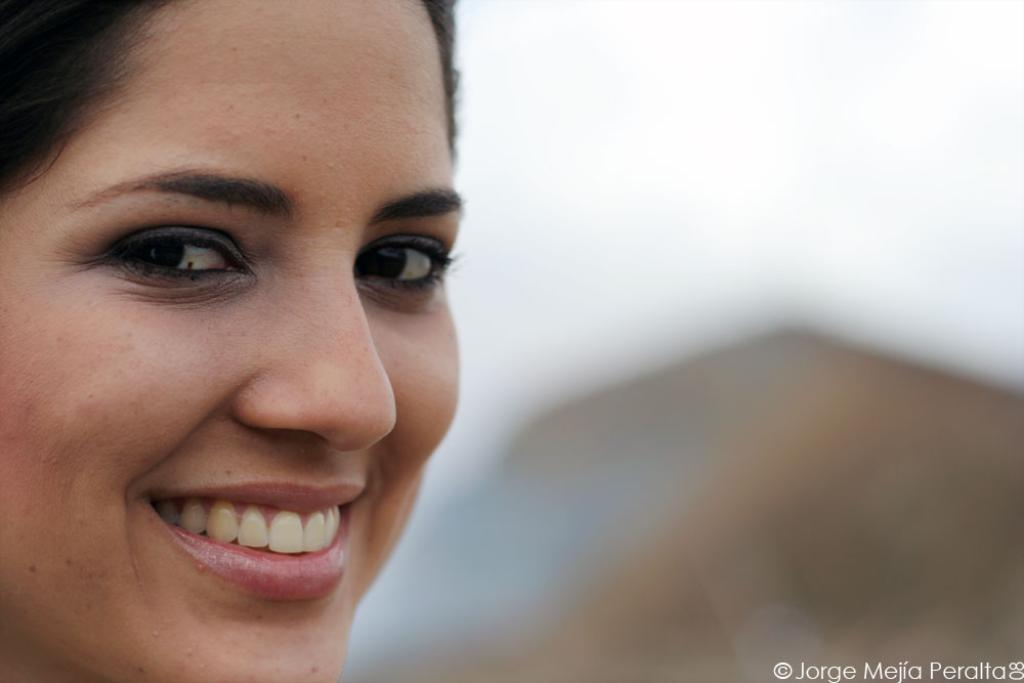What is the main subject of the image? There is a woman's face in the image. Are there any additional elements present in the image? Yes, there is a watermark in the image. How would you describe the overall quality of the image? The image is blurry in the background. What type of appliance can be seen in the woman's mouth in the image? There is no appliance visible in the woman's mouth in the image. Does the woman have fangs in the image? There is no indication of fangs in the image; it only shows a woman's face. 